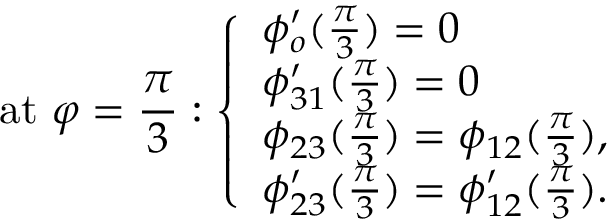<formula> <loc_0><loc_0><loc_500><loc_500>a t \varphi = \frac { \pi } { 3 } \colon \left \{ \begin{array} { l l } { \phi _ { o } ^ { \prime } ( \frac { \pi } { 3 } ) = 0 } \\ { \phi _ { 3 1 } ^ { \prime } ( \frac { \pi } { 3 } ) = 0 } \\ { \phi _ { 2 3 } ( \frac { \pi } { 3 } ) = \phi _ { 1 2 } ( \frac { \pi } { 3 } ) , } \\ { \phi _ { 2 3 } ^ { \prime } ( \frac { \pi } { 3 } ) = \phi _ { 1 2 } ^ { \prime } ( \frac { \pi } { 3 } ) . } \end{array}</formula> 